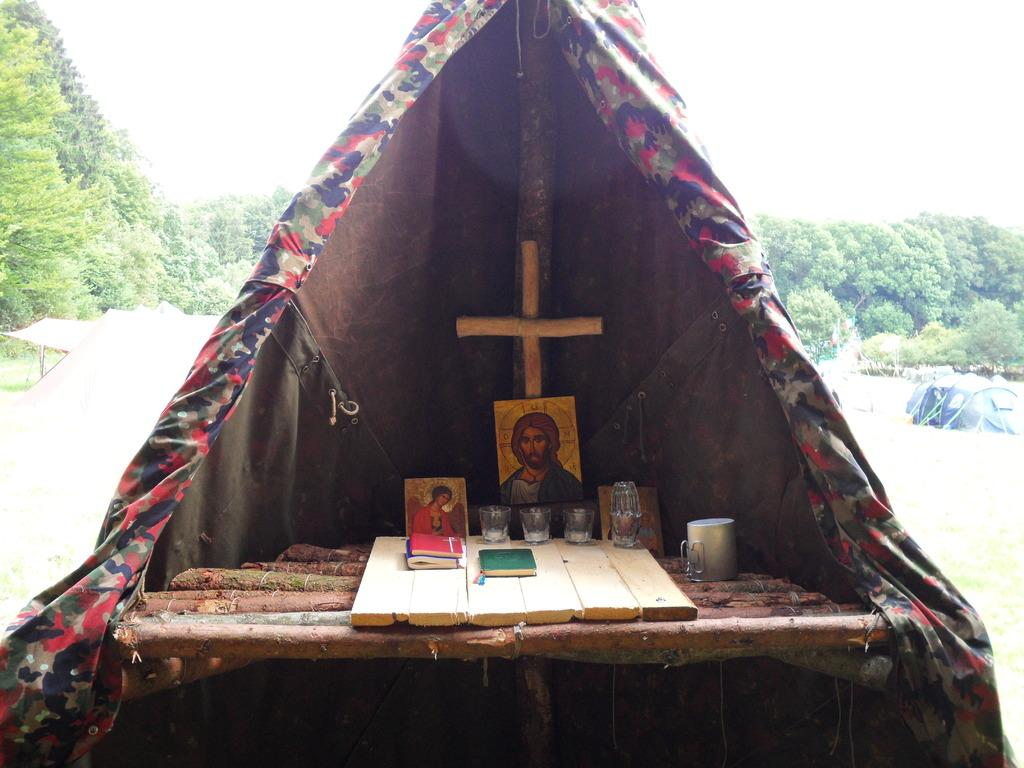Where was the image taken? The image was clicked outside. What can be seen on the left side of the image? There are trees on the left side of the image. What can be seen on the right side of the image? There are trees on the right side of the image. What is located in the middle of the image? There is a tent in the middle of the image. What items can be found inside the tent? There are photo frames, glasses, and a book inside the tent. What type of gate can be seen in the image? There is no gate present in the image. Can you see a train passing by in the image? There is no train present in the image. 